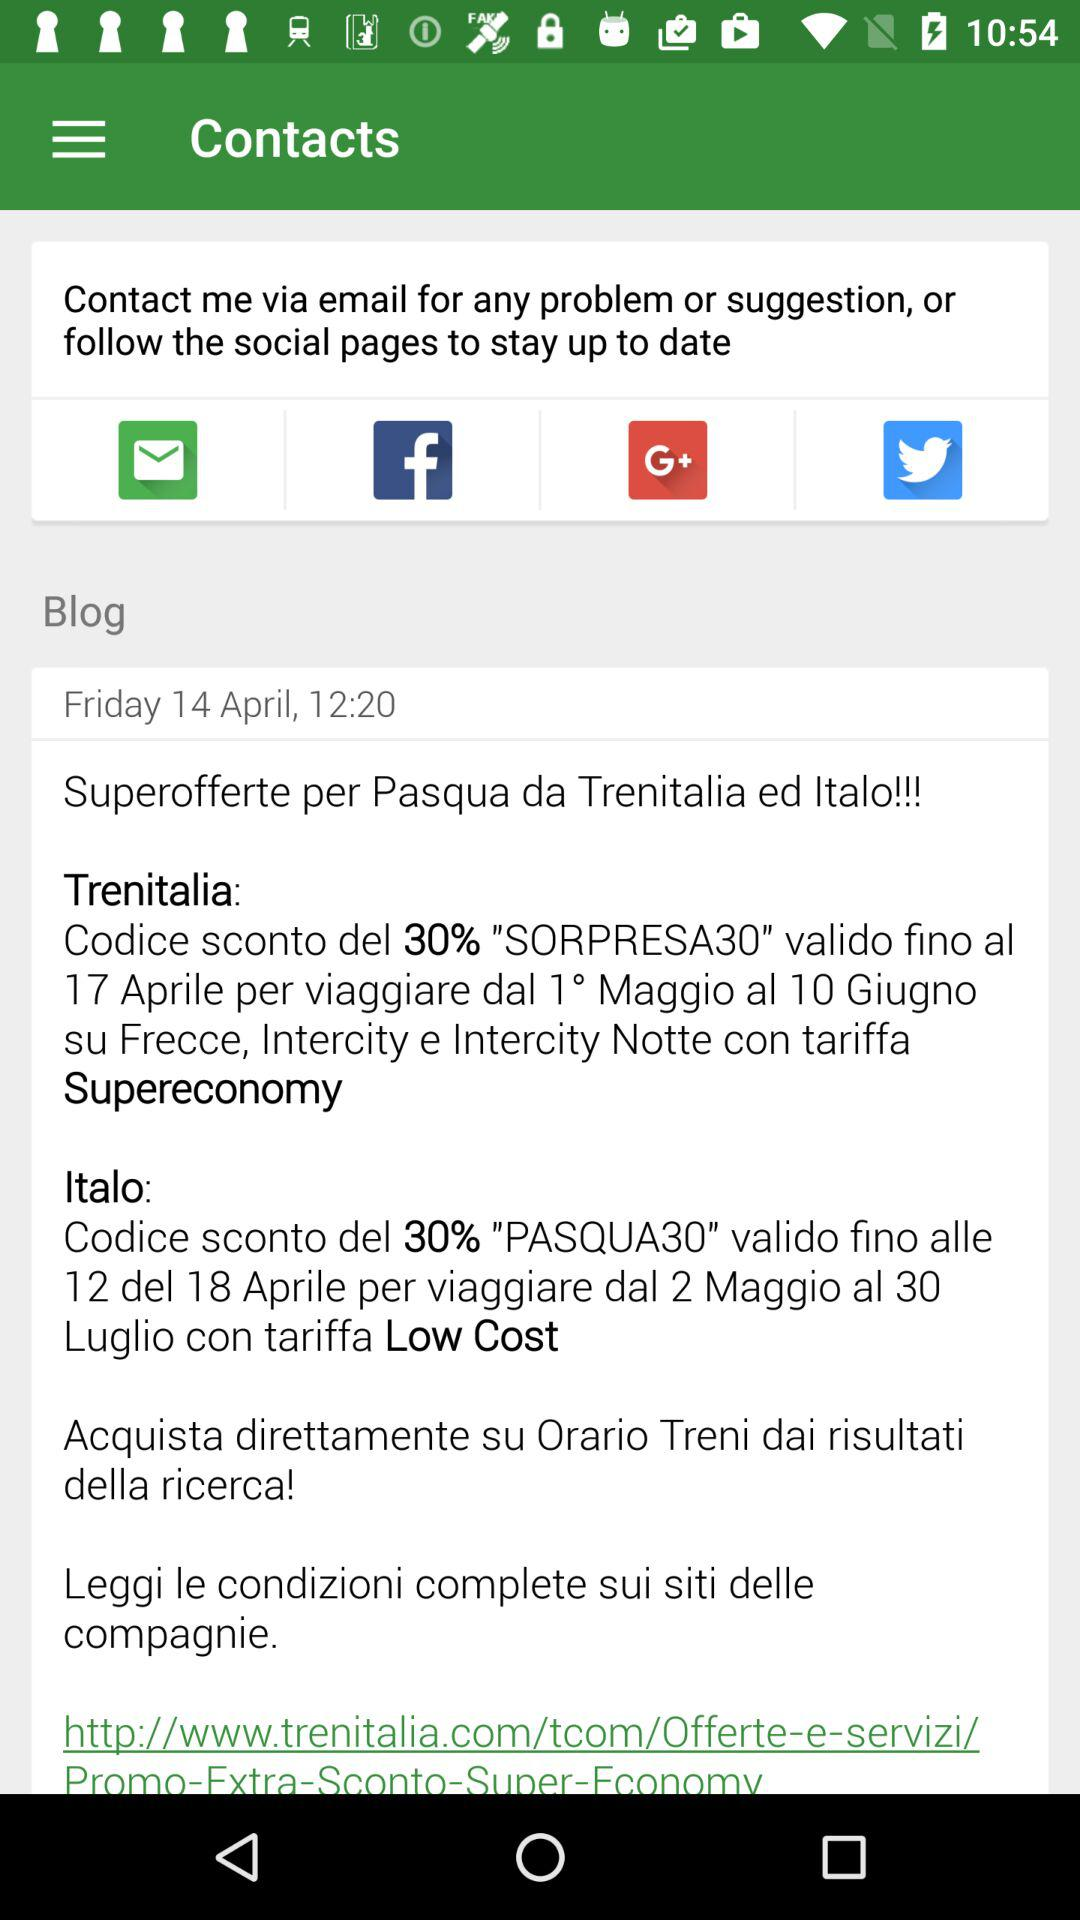What is the post date of the blog? The post date of the blog is Friday, April 14. 